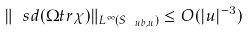<formula> <loc_0><loc_0><loc_500><loc_500>\| \ s d ( \Omega t r \chi ) \| _ { L ^ { \infty } ( S _ { \ u b , u } ) } \leq O ( | u | ^ { - 3 } )</formula> 